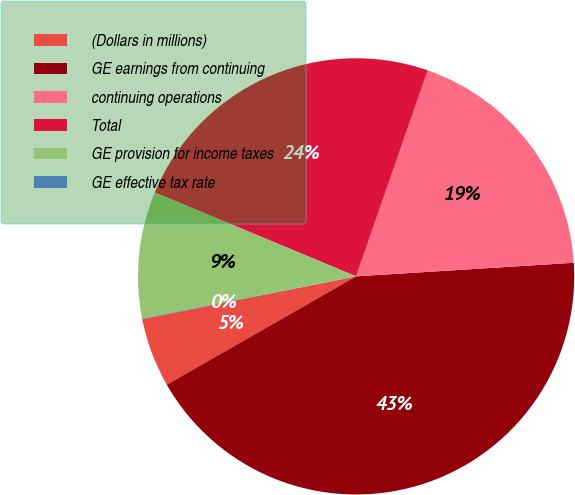Convert chart to OTSL. <chart><loc_0><loc_0><loc_500><loc_500><pie_chart><fcel>(Dollars in millions)<fcel>GE earnings from continuing<fcel>continuing operations<fcel>Total<fcel>GE provision for income taxes<fcel>GE effective tax rate<nl><fcel>5.12%<fcel>42.72%<fcel>18.68%<fcel>24.04%<fcel>9.38%<fcel>0.05%<nl></chart> 